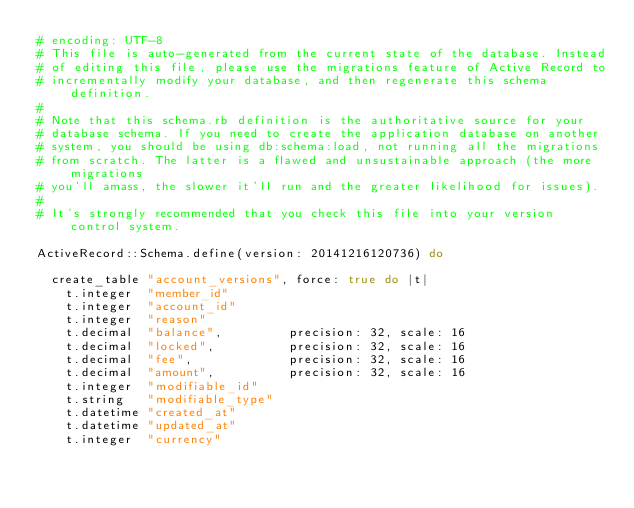<code> <loc_0><loc_0><loc_500><loc_500><_Ruby_># encoding: UTF-8
# This file is auto-generated from the current state of the database. Instead
# of editing this file, please use the migrations feature of Active Record to
# incrementally modify your database, and then regenerate this schema definition.
#
# Note that this schema.rb definition is the authoritative source for your
# database schema. If you need to create the application database on another
# system, you should be using db:schema:load, not running all the migrations
# from scratch. The latter is a flawed and unsustainable approach (the more migrations
# you'll amass, the slower it'll run and the greater likelihood for issues).
#
# It's strongly recommended that you check this file into your version control system.

ActiveRecord::Schema.define(version: 20141216120736) do

  create_table "account_versions", force: true do |t|
    t.integer  "member_id"
    t.integer  "account_id"
    t.integer  "reason"
    t.decimal  "balance",         precision: 32, scale: 16
    t.decimal  "locked",          precision: 32, scale: 16
    t.decimal  "fee",             precision: 32, scale: 16
    t.decimal  "amount",          precision: 32, scale: 16
    t.integer  "modifiable_id"
    t.string   "modifiable_type"
    t.datetime "created_at"
    t.datetime "updated_at"
    t.integer  "currency"</code> 